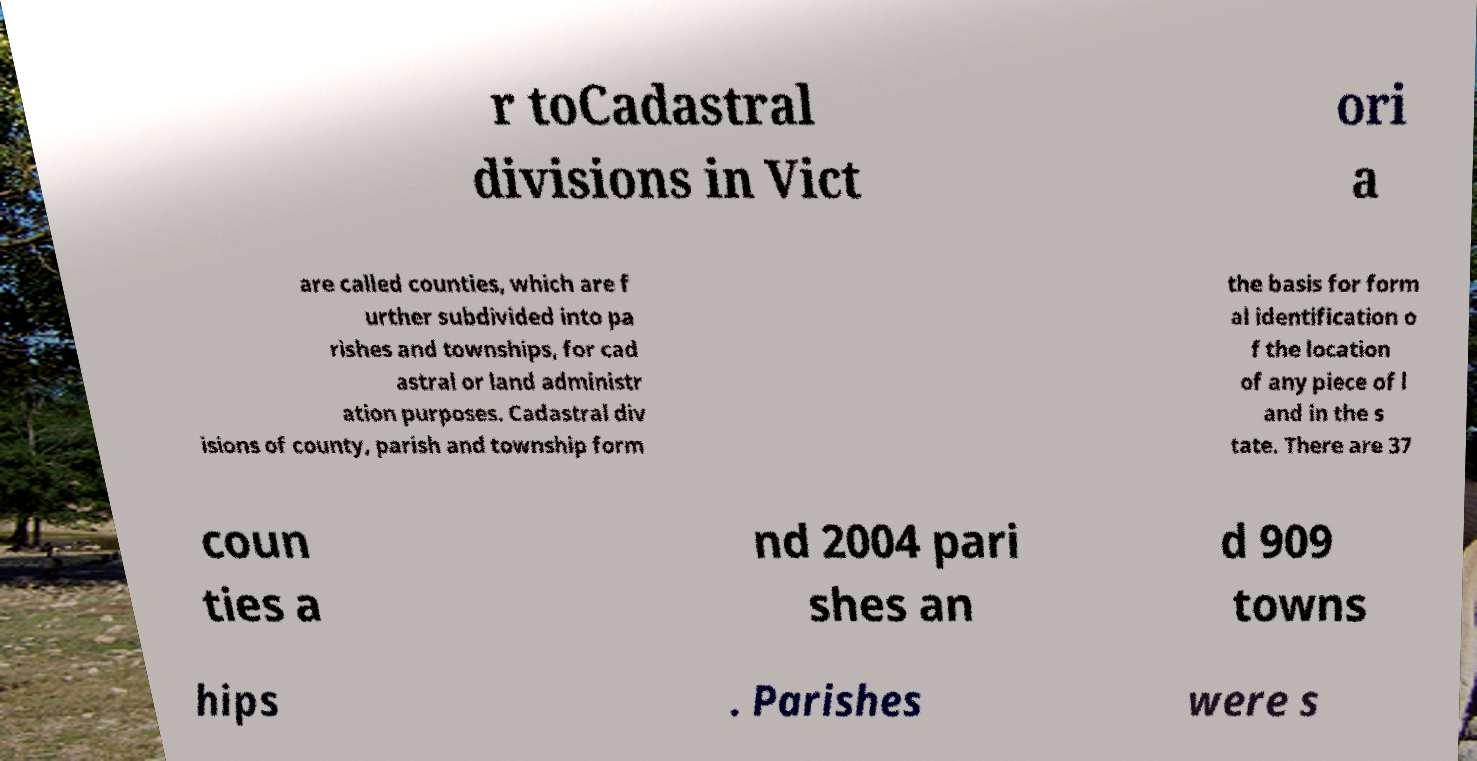There's text embedded in this image that I need extracted. Can you transcribe it verbatim? r toCadastral divisions in Vict ori a are called counties, which are f urther subdivided into pa rishes and townships, for cad astral or land administr ation purposes. Cadastral div isions of county, parish and township form the basis for form al identification o f the location of any piece of l and in the s tate. There are 37 coun ties a nd 2004 pari shes an d 909 towns hips . Parishes were s 